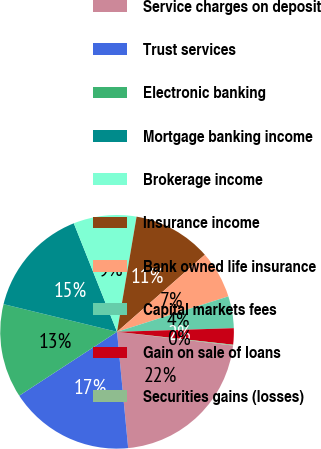Convert chart. <chart><loc_0><loc_0><loc_500><loc_500><pie_chart><fcel>Service charges on deposit<fcel>Trust services<fcel>Electronic banking<fcel>Mortgage banking income<fcel>Brokerage income<fcel>Insurance income<fcel>Bank owned life insurance<fcel>Capital markets fees<fcel>Gain on sale of loans<fcel>Securities gains (losses)<nl><fcel>21.61%<fcel>17.31%<fcel>13.01%<fcel>15.16%<fcel>8.71%<fcel>10.86%<fcel>6.56%<fcel>4.41%<fcel>2.26%<fcel>0.11%<nl></chart> 